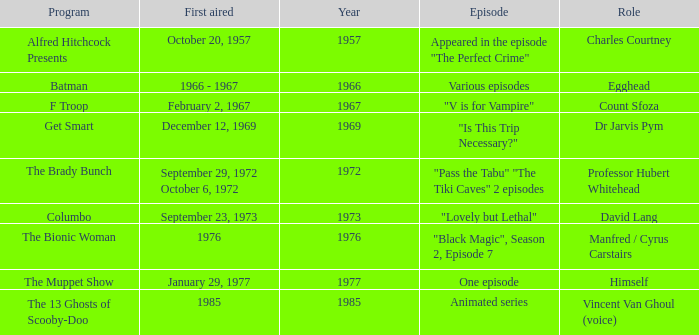What's the first aired date when Professor Hubert Whitehead was the role? September 29, 1972 October 6, 1972. Write the full table. {'header': ['Program', 'First aired', 'Year', 'Episode', 'Role'], 'rows': [['Alfred Hitchcock Presents', 'October 20, 1957', '1957', 'Appeared in the episode "The Perfect Crime"', 'Charles Courtney'], ['Batman', '1966 - 1967', '1966', 'Various episodes', 'Egghead'], ['F Troop', 'February 2, 1967', '1967', '"V is for Vampire"', 'Count Sfoza'], ['Get Smart', 'December 12, 1969', '1969', '"Is This Trip Necessary?"', 'Dr Jarvis Pym'], ['The Brady Bunch', 'September 29, 1972 October 6, 1972', '1972', '"Pass the Tabu" "The Tiki Caves" 2 episodes', 'Professor Hubert Whitehead'], ['Columbo', 'September 23, 1973', '1973', '"Lovely but Lethal"', 'David Lang'], ['The Bionic Woman', '1976', '1976', '"Black Magic", Season 2, Episode 7', 'Manfred / Cyrus Carstairs'], ['The Muppet Show', 'January 29, 1977', '1977', 'One episode', 'Himself'], ['The 13 Ghosts of Scooby-Doo', '1985', '1985', 'Animated series', 'Vincent Van Ghoul (voice)']]} 